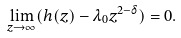<formula> <loc_0><loc_0><loc_500><loc_500>\lim _ { z \rightarrow \infty } ( h ( z ) - \lambda _ { 0 } z ^ { 2 - \delta } ) = 0 .</formula> 